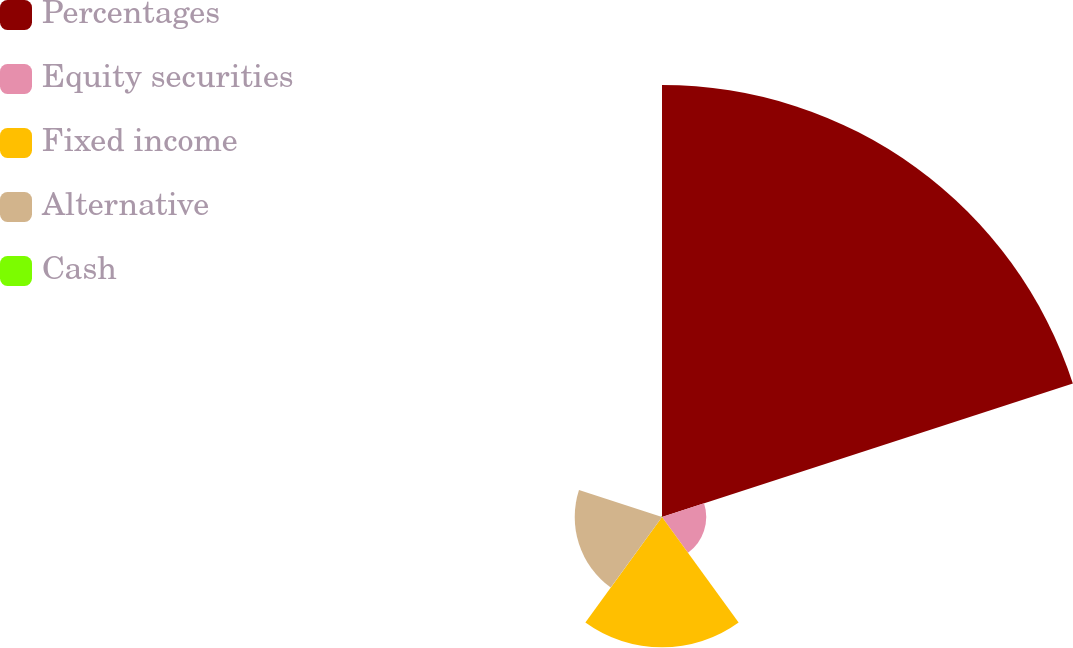Convert chart to OTSL. <chart><loc_0><loc_0><loc_500><loc_500><pie_chart><fcel>Percentages<fcel>Equity securities<fcel>Fixed income<fcel>Alternative<fcel>Cash<nl><fcel>62.17%<fcel>6.36%<fcel>18.76%<fcel>12.56%<fcel>0.15%<nl></chart> 